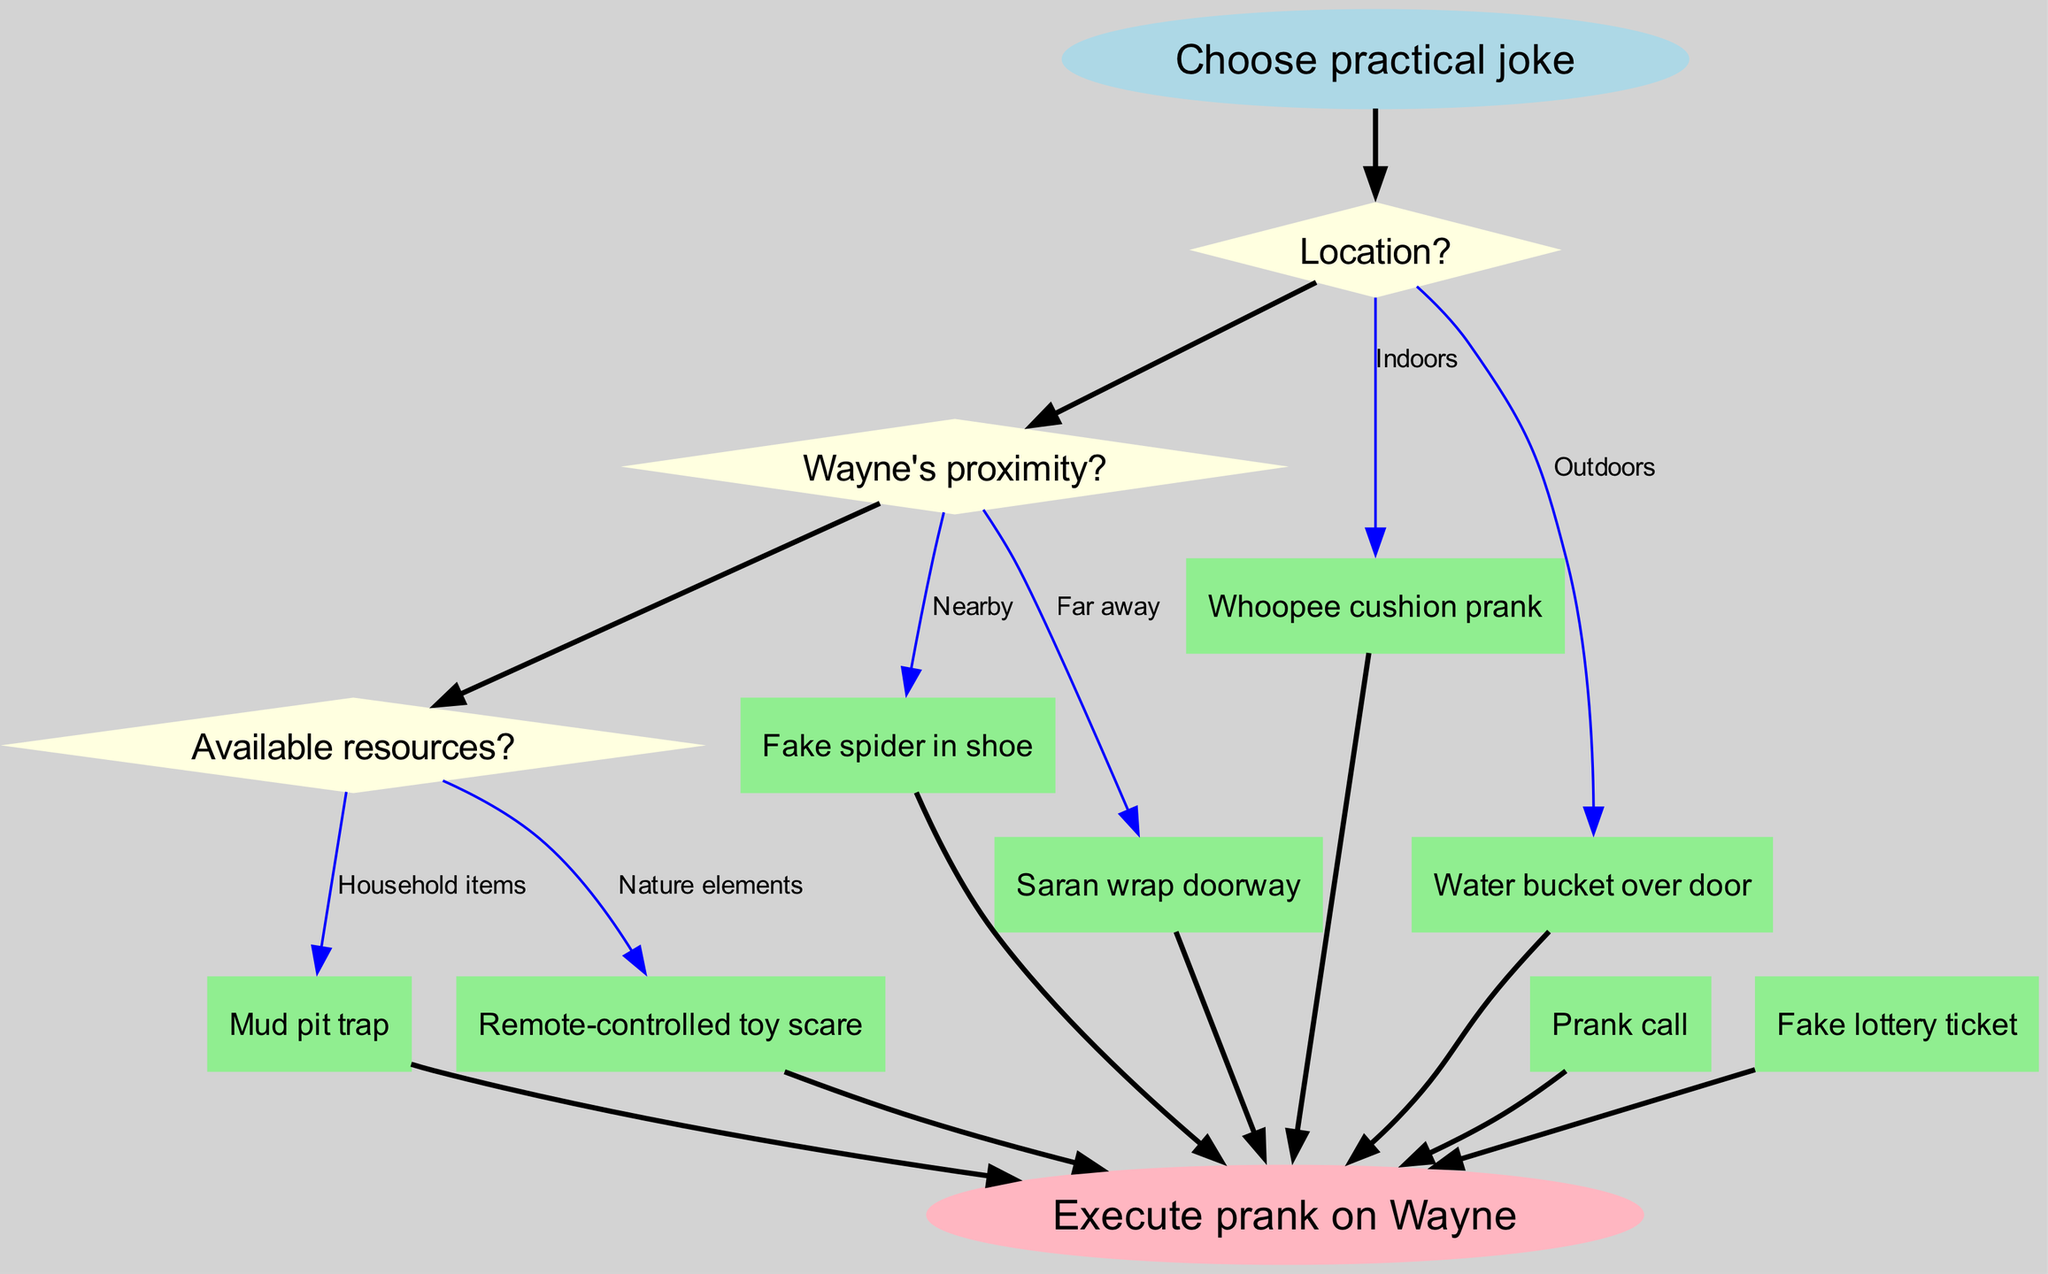What is the starting point of the diagram? The starting point of the diagram is labeled as "Choose practical joke," indicating where the process begins before making any decisions.
Answer: Choose practical joke How many decision nodes are there in the diagram? There are three decision nodes in the diagram, as indicated by the number of questions presented regarding location, Wayne's proximity, and available resources.
Answer: 3 What are the available resources options in the second decision node? The available resources options in the second decision node include "Household items" and "Nature elements," reflecting what can be utilized for the prank.
Answer: Household items and Nature elements Which outcome is related to using household items indoors? The related outcome for using household items indoors is "Whoopee cushion prank," as it fits both criteria specified in the respective decision nodes.
Answer: Whoopee cushion prank If Wayne is far away and it is outdoors, which prank is chosen? If Wayne is far away and the location is outdoors, the decision will likely lead to "Mud pit trap," as it utilizes outdoor elements and indicates a prank setup while Wayne is not close.
Answer: Mud pit trap What happens after selecting a prank from the outcomes? After selecting a prank from the outcomes, the next step in the flowchart is to execute the chosen prank on Wayne, which concludes the process.
Answer: Execute prank on Wayne Which node connects the outcomes to the end of the process? The end of the process is connected by nodes labeled from "o0" to "o7," which represent the various prank options listed in the outcomes section before concluding the task.
Answer: o0 to o7 What is the total number of edges in the flowchart? The total number of edges includes all connections made between the start, decision nodes, outcome nodes, and the end, which sums up to ten edges overall.
Answer: 10 Which decision involves Wayne's proximity? The decision node that involves Wayne's proximity is the second one in the flowchart, specifically asking "Wayne's proximity?" as the relevant query to consider in the prank selection process.
Answer: Wayne's proximity 